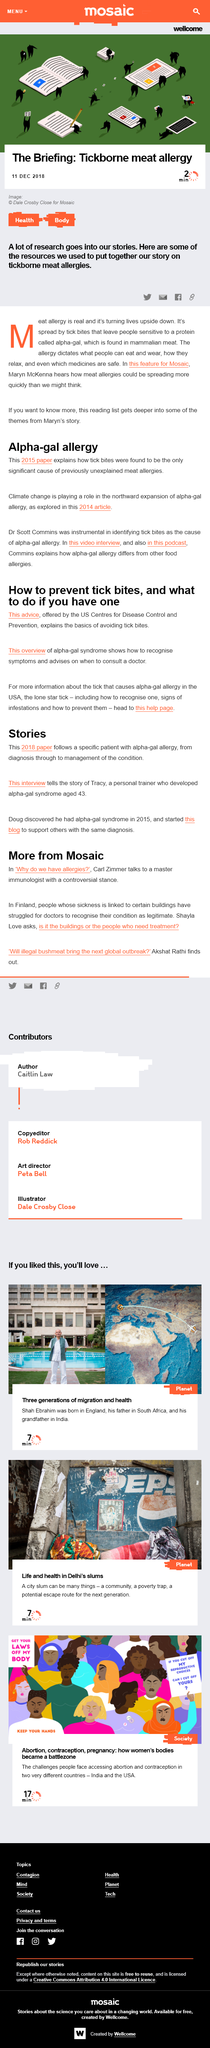Point out several critical features in this image. The Centers for Disease Control and Prevention (CDC) is the best source to find information about the tick that causes alpha-gal allergy in the United States. In 2015, Doug discovered that he had alpha-gal syndrome. Dr. Scott Commins was instrumental in identifying tick bites as the cause of alpha-gal allergy. Alpha-gal, a component of mammalian meat, can be found in various parts of mammals such as cows, pigs, and sheep. The advice offered by the US Centres for Disease Control and Prevention provides a comprehensive understanding of how to prevent tick bites. 